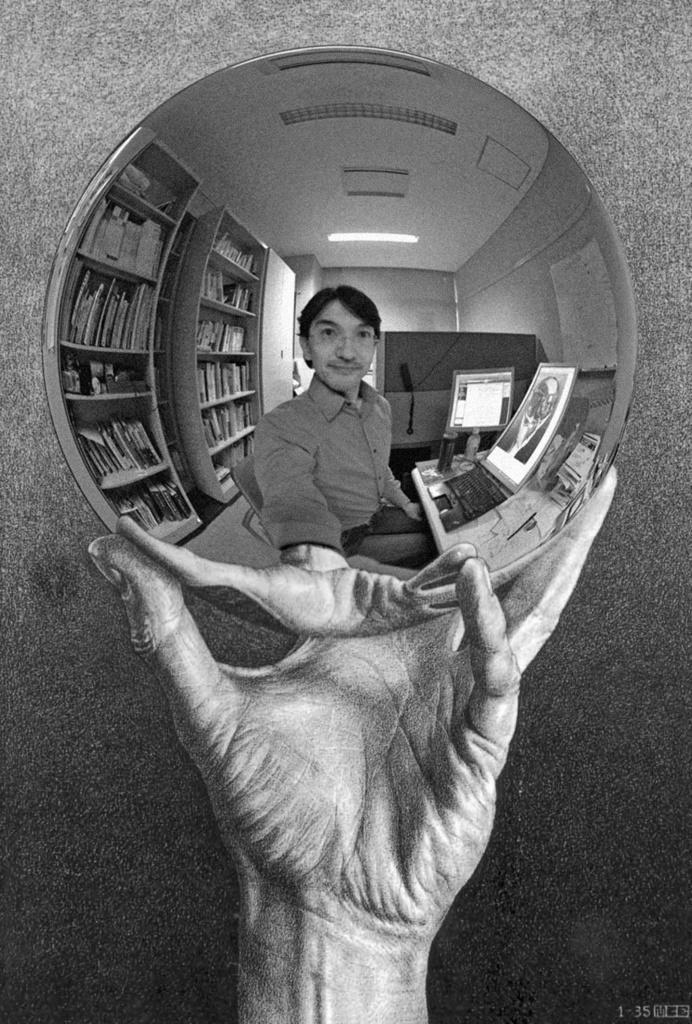Please provide a concise description of this image. In this image I can see the person holding the mirror. In the mirror I can see the person, system and few objects on the table. In the background I can see few books in the racks and the image is in black and white. 